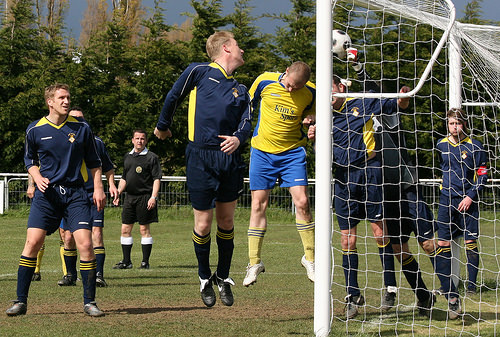<image>
Is there a man to the right of the man? Yes. From this viewpoint, the man is positioned to the right side relative to the man. Where is the man in relation to the man? Is it to the right of the man? Yes. From this viewpoint, the man is positioned to the right side relative to the man. 